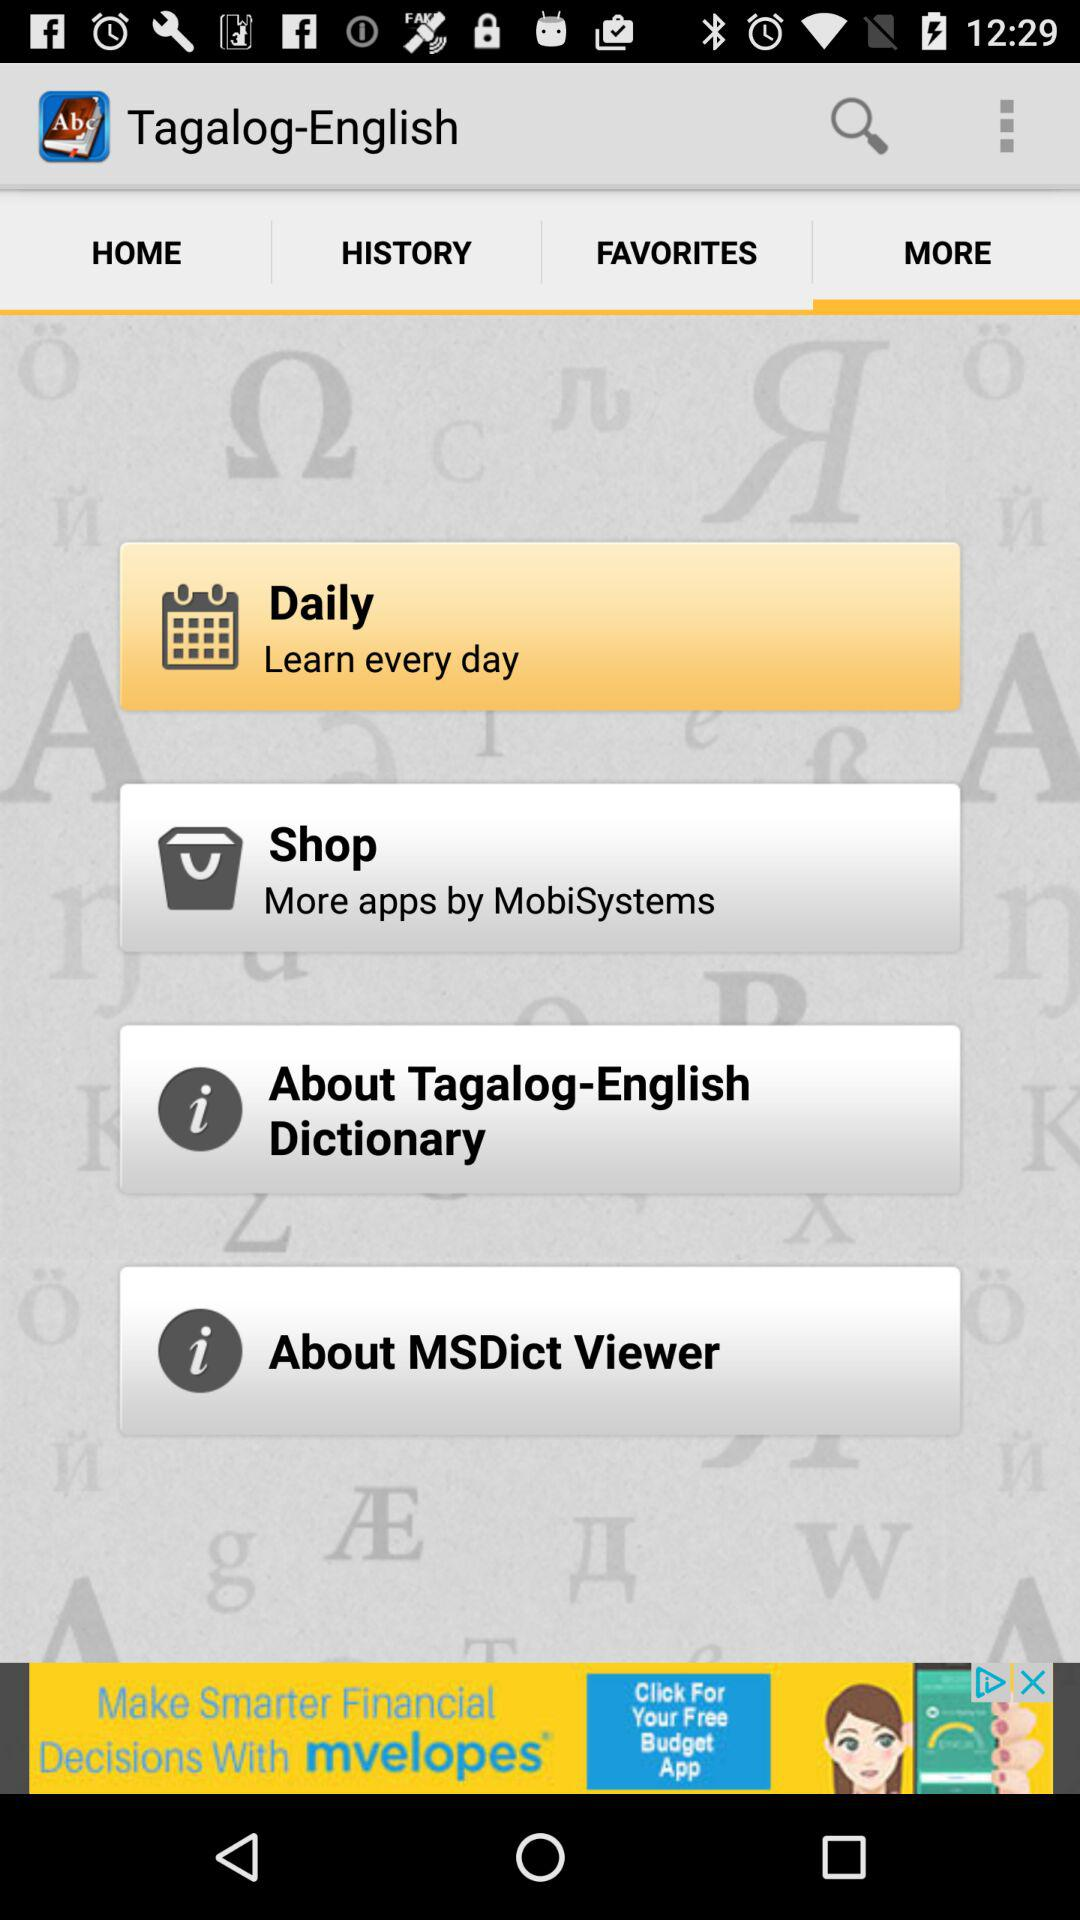When can we learn? You can learn every day. 